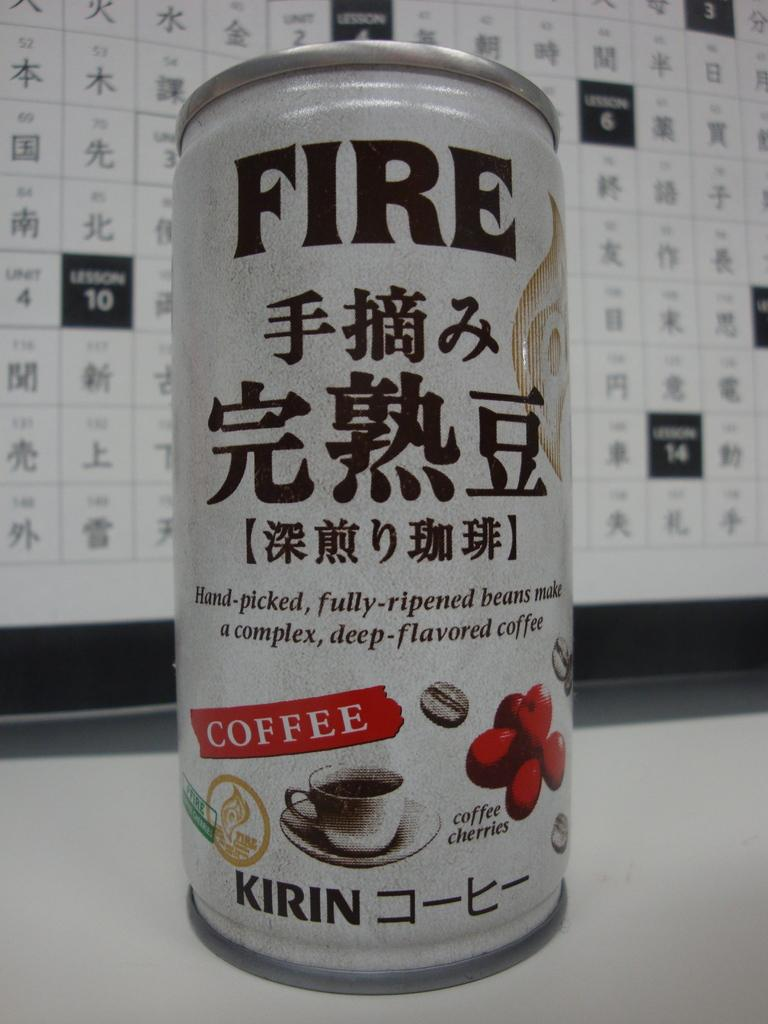<image>
Provide a brief description of the given image. A white can of Fire coffee made by Kirin. 